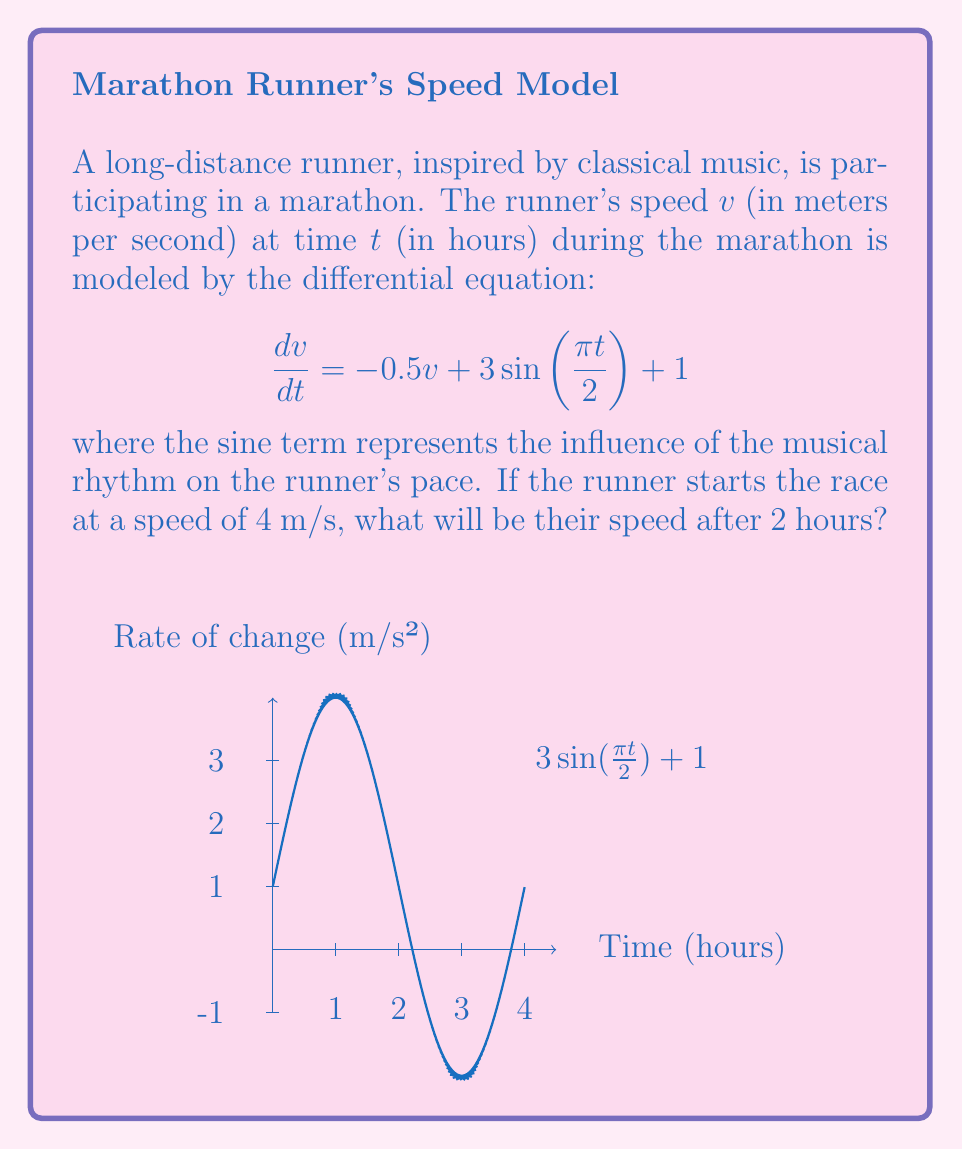Can you answer this question? To solve this first-order linear differential equation, we'll use the integrating factor method:

1) The equation is in the form $\frac{dv}{dt} + 0.5v = 3\sin(\frac{\pi t}{2}) + 1$

2) The integrating factor is $\mu(t) = e^{\int 0.5 dt} = e^{0.5t}$

3) Multiply both sides by $\mu(t)$:

   $e^{0.5t}\frac{dv}{dt} + 0.5e^{0.5t}v = e^{0.5t}(3\sin(\frac{\pi t}{2}) + 1)$

4) The left side is now the derivative of $e^{0.5t}v$:

   $\frac{d}{dt}(e^{0.5t}v) = e^{0.5t}(3\sin(\frac{\pi t}{2}) + 1)$

5) Integrate both sides:

   $e^{0.5t}v = \int e^{0.5t}(3\sin(\frac{\pi t}{2}) + 1) dt$

6) Solve the integral:

   $e^{0.5t}v = 3\int e^{0.5t}\sin(\frac{\pi t}{2}) dt + \int e^{0.5t} dt$
   
   $= 3(\frac{2e^{0.5t}}{0.5^2 + (\frac{\pi}{2})^2}(0.5\sin(\frac{\pi t}{2}) - \frac{\pi}{2}\cos(\frac{\pi t}{2}))) + 2e^{0.5t} + C$

7) Solve for $v$:

   $v = \frac{6}{0.25 + (\frac{\pi}{2})^2}(0.5\sin(\frac{\pi t}{2}) - \frac{\pi}{2}\cos(\frac{\pi t}{2})) + 2 + Ce^{-0.5t}$

8) Use the initial condition $v(0) = 4$ to find $C$:

   $4 = \frac{6}{0.25 + (\frac{\pi}{2})^2}(-\frac{\pi}{2}) + 2 + C$
   
   $C = 2 + \frac{3\pi}{0.25 + (\frac{\pi}{2})^2}$

9) Substitute $t = 2$ into the solution:

   $v(2) = \frac{6}{0.25 + (\frac{\pi}{2})^2}(0.5\sin(\pi) - \frac{\pi}{2}\cos(\pi)) + 2 + (2 + \frac{3\pi}{0.25 + (\frac{\pi}{2})^2})e^{-1}$

10) Simplify and calculate the final result.
Answer: $v(2) \approx 3.62$ m/s 